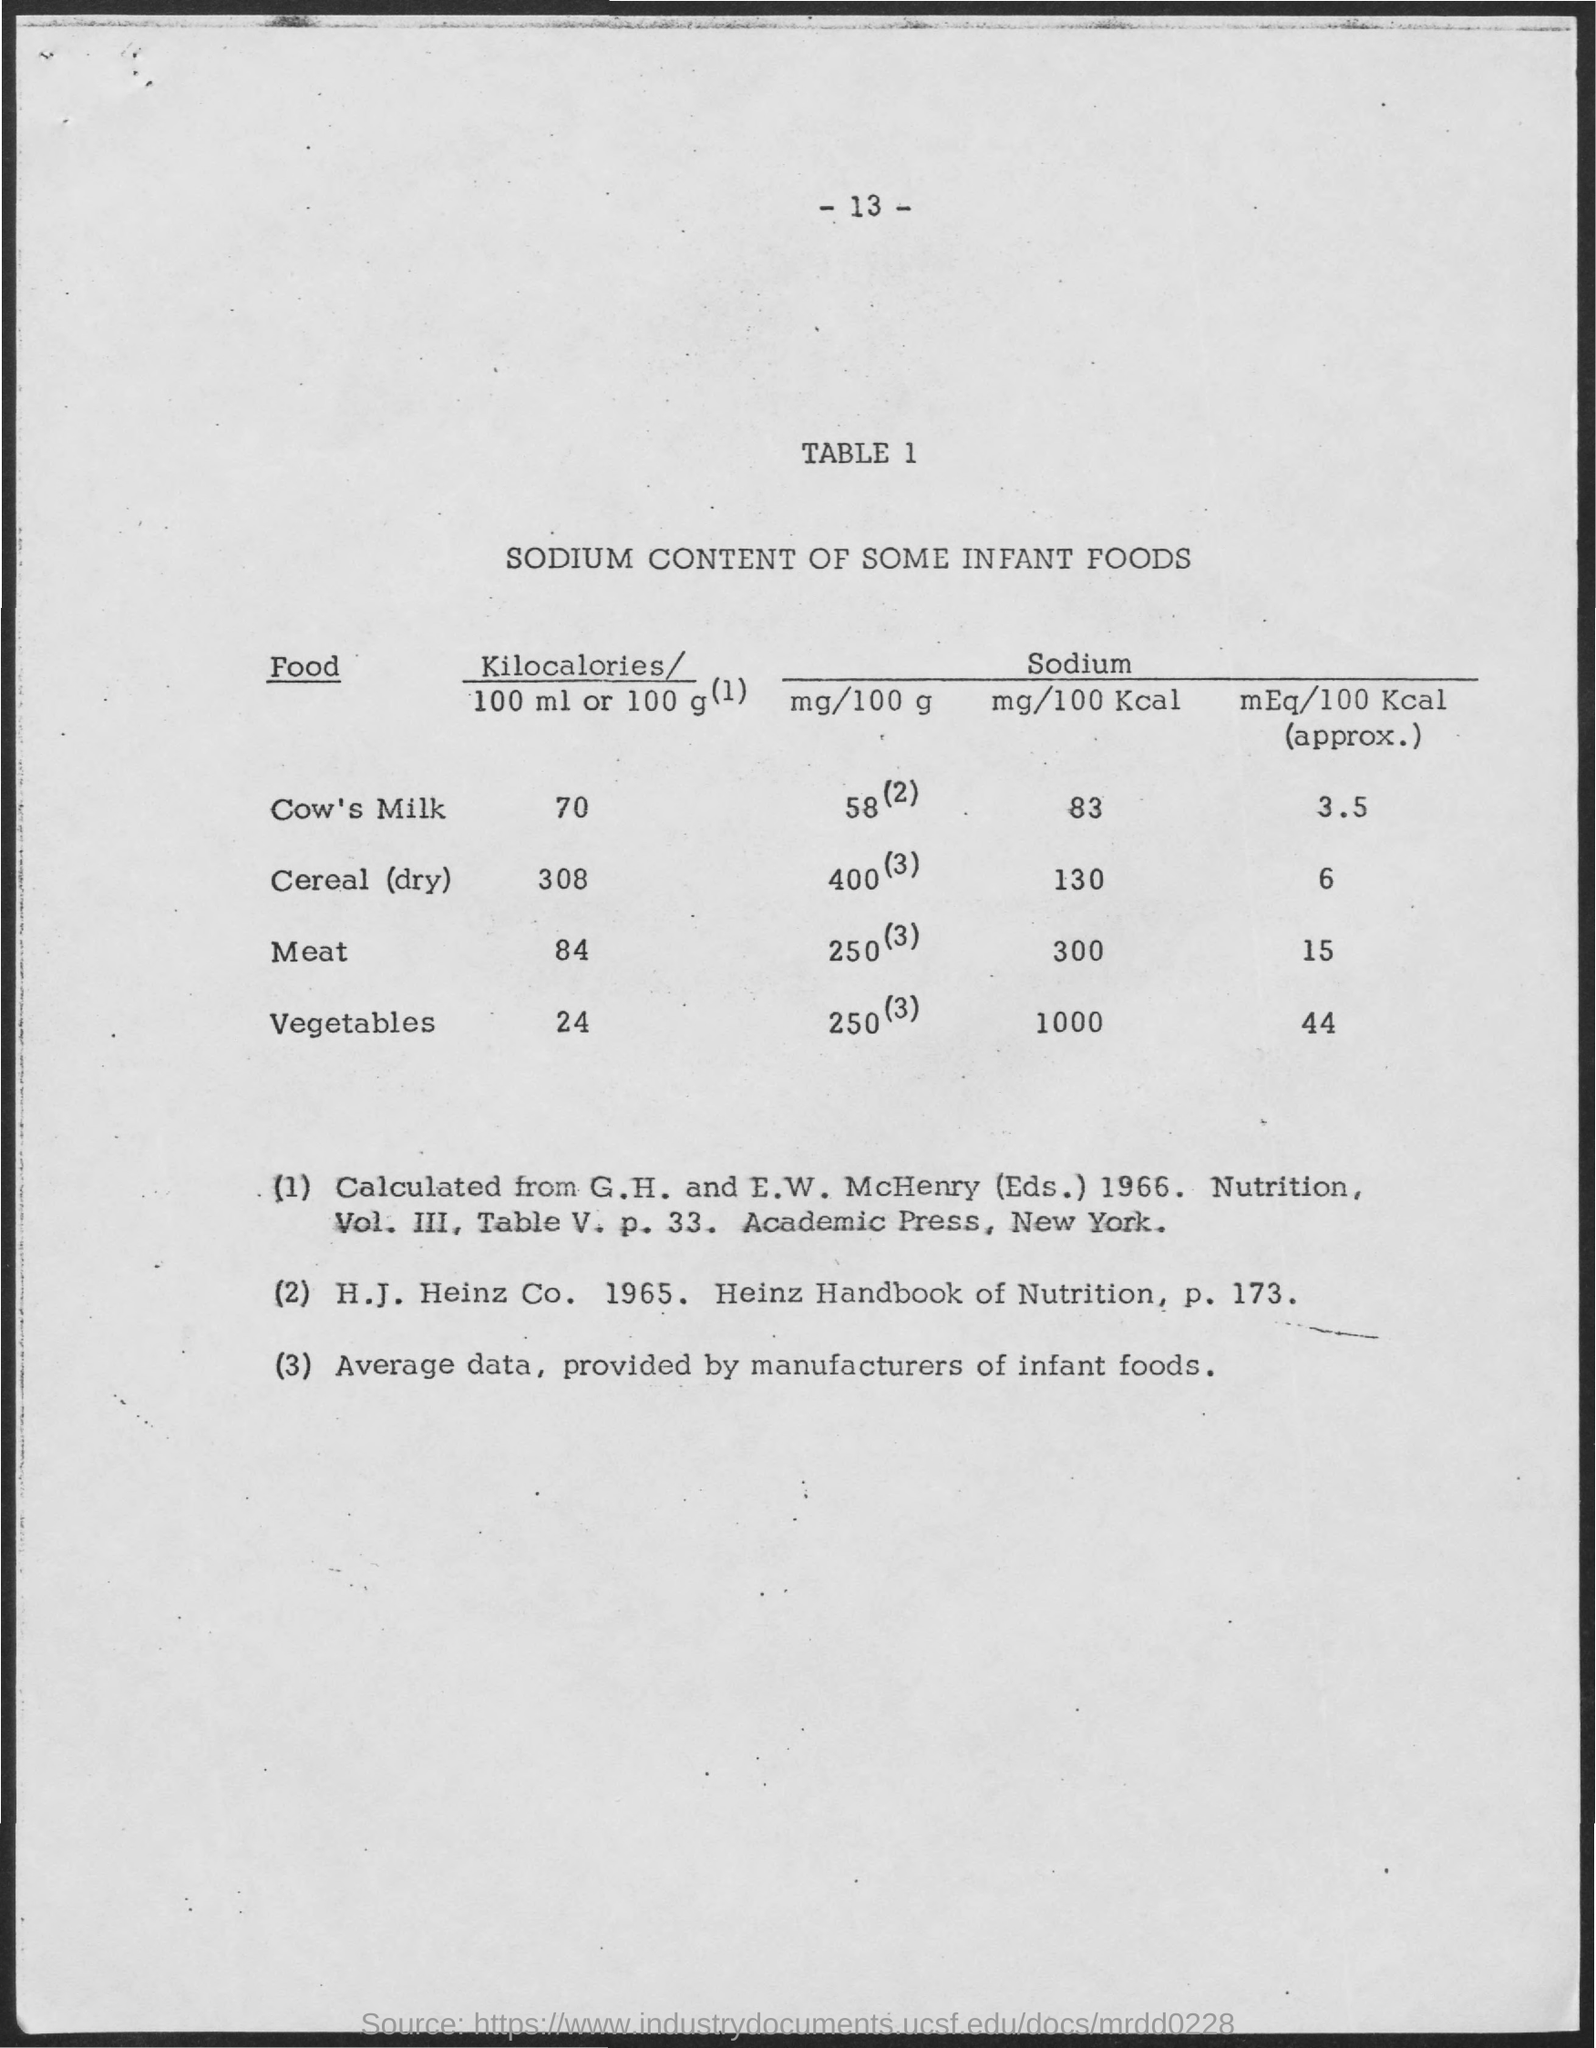Identify some key points in this picture. The sodium content of cow's milk is approximately 3.5 milliequivalents per 100 calories. The sodium content of vegetables is approximately 44 milliequivalents per 100 calories. The sodium content in vegetables is typically expressed in milligrams per 100 calories. The sodium content in 100 calories of cereal (dry) is 130 milligrams. The sodium content (approximately) for dry cereal is 6 mEq/100 Kcal. 